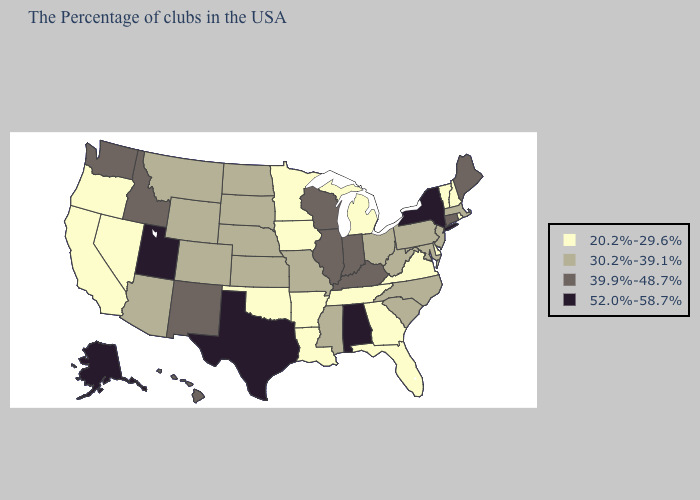Does Nebraska have the same value as Hawaii?
Concise answer only. No. What is the highest value in states that border Oregon?
Keep it brief. 39.9%-48.7%. What is the value of Washington?
Write a very short answer. 39.9%-48.7%. Name the states that have a value in the range 52.0%-58.7%?
Keep it brief. New York, Alabama, Texas, Utah, Alaska. What is the lowest value in the Northeast?
Be succinct. 20.2%-29.6%. Does Mississippi have the lowest value in the USA?
Keep it brief. No. What is the highest value in the USA?
Give a very brief answer. 52.0%-58.7%. Does Kansas have the highest value in the MidWest?
Answer briefly. No. Is the legend a continuous bar?
Short answer required. No. What is the highest value in the West ?
Write a very short answer. 52.0%-58.7%. Among the states that border Tennessee , does Alabama have the highest value?
Give a very brief answer. Yes. What is the value of Kentucky?
Quick response, please. 39.9%-48.7%. What is the lowest value in the USA?
Answer briefly. 20.2%-29.6%. What is the value of Utah?
Concise answer only. 52.0%-58.7%. Does New York have the highest value in the USA?
Write a very short answer. Yes. 